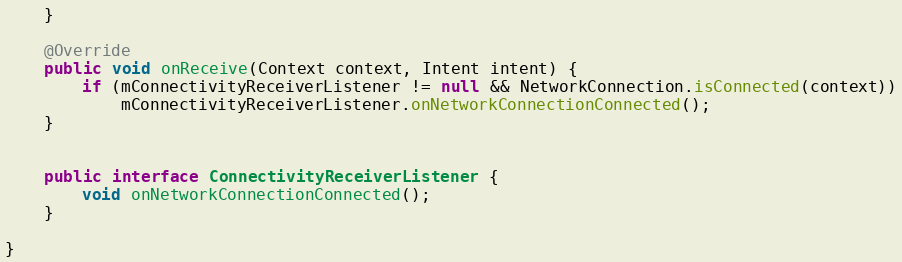Convert code to text. <code><loc_0><loc_0><loc_500><loc_500><_Java_>    }

    @Override
    public void onReceive(Context context, Intent intent) {
        if (mConnectivityReceiverListener != null && NetworkConnection.isConnected(context))
            mConnectivityReceiverListener.onNetworkConnectionConnected();
    }


    public interface ConnectivityReceiverListener {
        void onNetworkConnectionConnected();
    }

}
</code> 